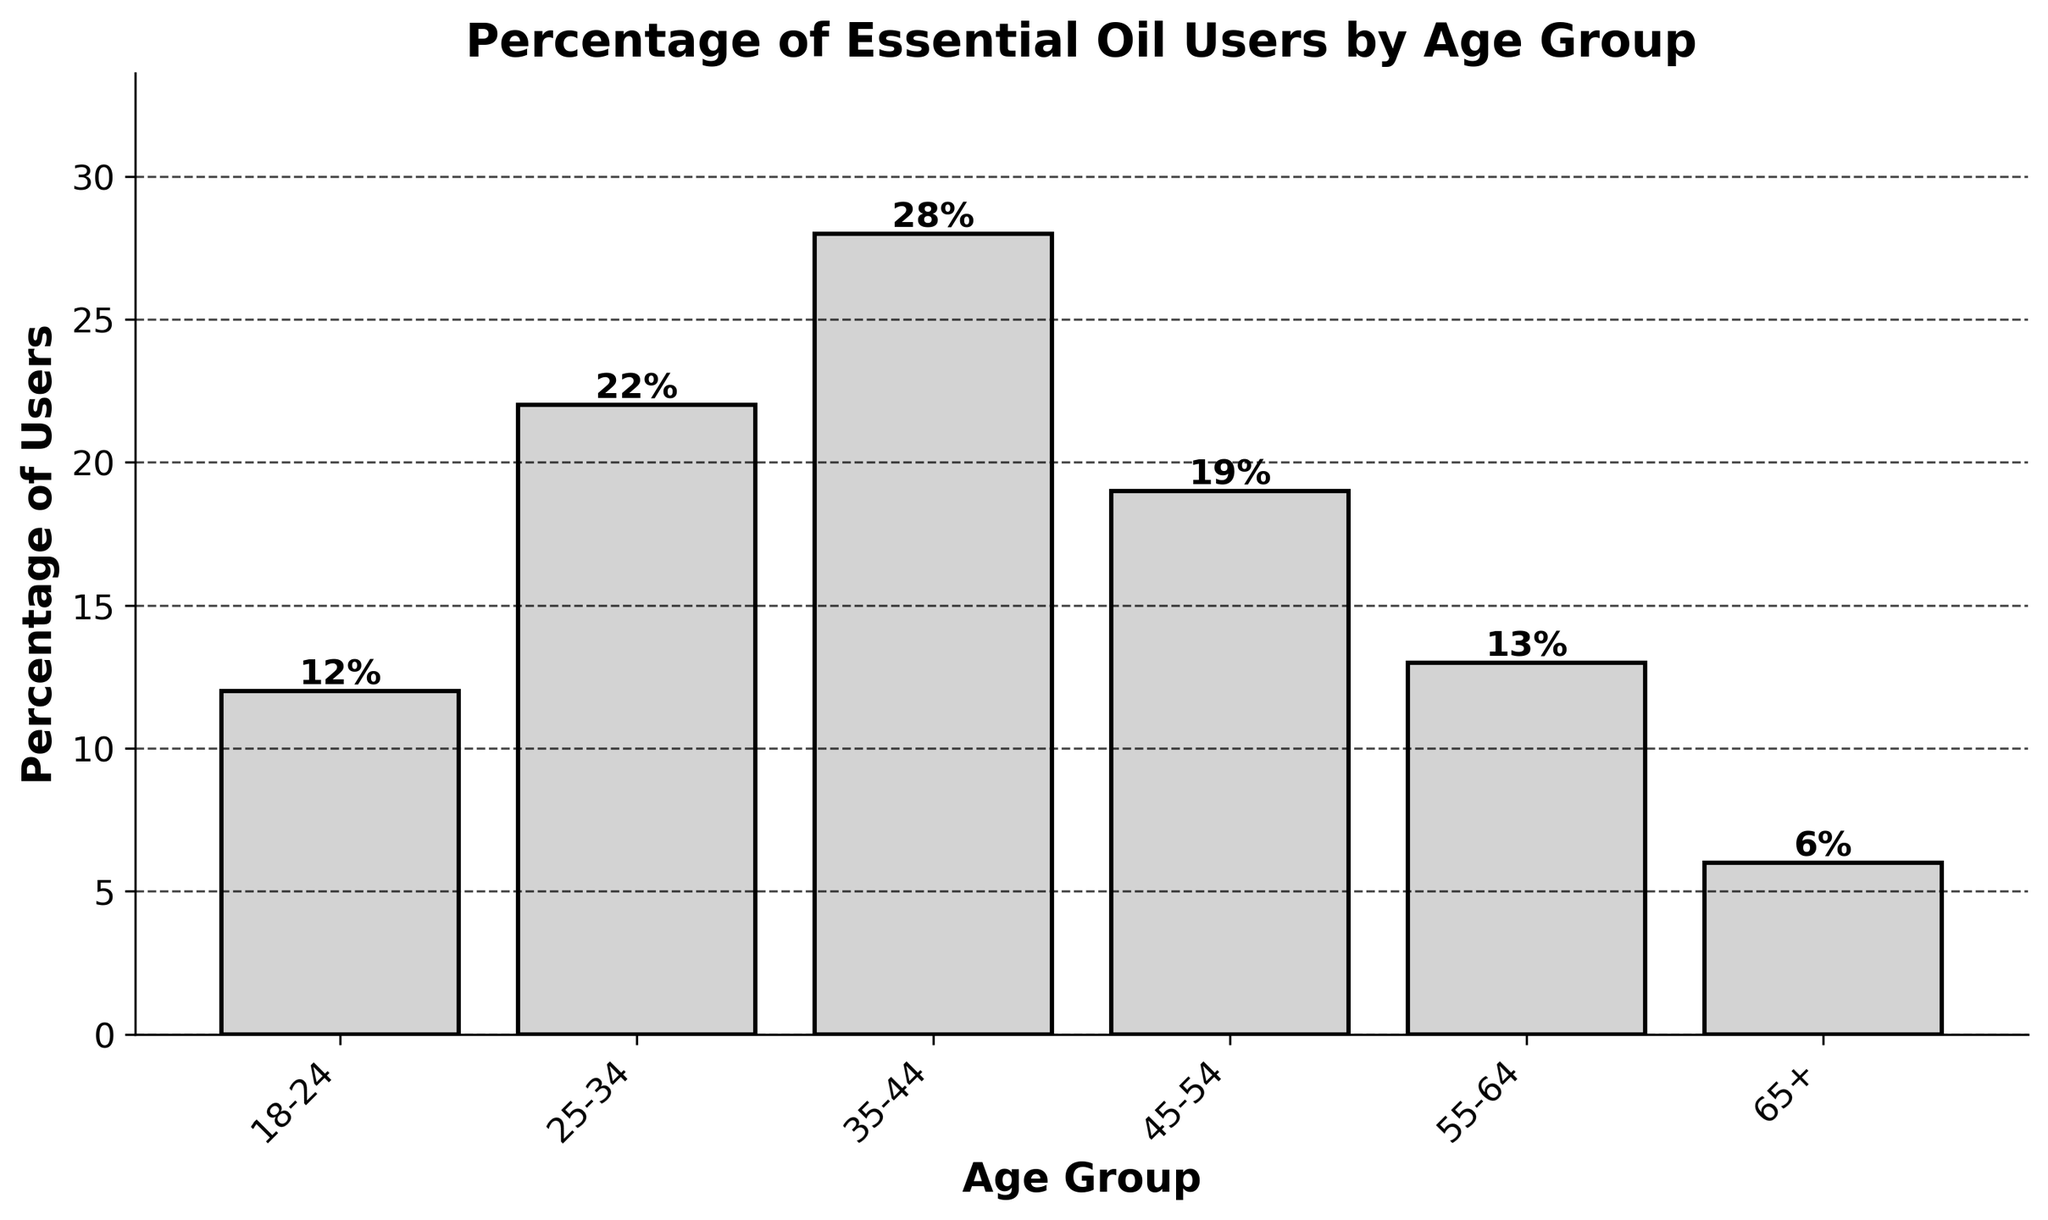What is the percentage of essential oil users in the 25-34 age group? Look at the bar corresponding to the 25-34 age group. The height of the bar represents the percentage, which is labeled as 22% on top of it.
Answer: 22% Which age group has the highest percentage of essential oil users? Look at the heights of all the bars and identify the tallest one. The tallest bar is for the 35-44 age group, indicating that it has the highest percentage of users.
Answer: 35-44 How much greater is the percentage of essential oil users in the 35-44 age group compared to the 65+ age group? Subtract the percentage of the 65+ age group (6%) from the percentage of the 35-44 age group (28%). 28% - 6% = 22%.
Answer: 22% What is the difference in the percentage of essential oil users between the 18-24 and 55-64 age groups? Subtract the percentage of the 55-64 age group (13%) from the percentage of the 18-24 age group (12%). 13% - 12% = 1%.
Answer: 1% Which age groups have a percentage of essential oil users less than 20%? Look at the bars that are below the 20% mark. The age groups with percentages less than 20% are 18-24, 55-64, and 65+.
Answer: 18-24, 55-64, 65+ What is the average percentage of essential oil users among the 25-34, 45-54, and 55-64 age groups? Add the percentages of the 25-34 (22%), 45-54 (19%), and 55-64 (13%) age groups, then divide by 3. (22% + 19% + 13%) / 3 = 54% / 3 = 18%.
Answer: 18% Is the percentage of essential oil users in the 45-54 age group closer to the 25-34 or the 55-64 age group? Calculate the absolute differences of the 45-54 age group (19%) with the 25-34 (22%) and the 55-64 (13%) age groups. 22% - 19% = 3%; 19% - 13% = 6%. The smaller difference indicates it is closer to 25-34.
Answer: 25-34 What is the total percentage of essential oil users for age groups under 35 years old? Add the percentages of the 18-24 (12%) and 25-34 (22%) age groups. 12% + 22% = 34%.
Answer: 34% How does the percentage of the 35-44 age group compare to the sum of the 65+ and 18-24 age groups? Add the percentages of the 65+ (6%) and 18-24 (12%) age groups, then compare to the 35-44 (28%). 6% + 12% = 18%, which is less than 28%.
Answer: Greater 